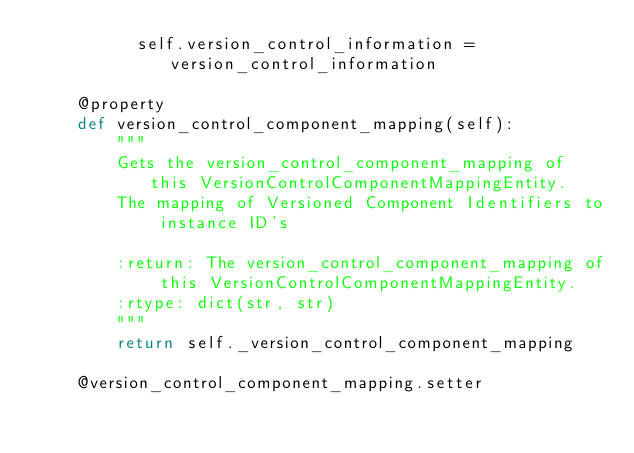Convert code to text. <code><loc_0><loc_0><loc_500><loc_500><_Python_>          self.version_control_information = version_control_information

    @property
    def version_control_component_mapping(self):
        """
        Gets the version_control_component_mapping of this VersionControlComponentMappingEntity.
        The mapping of Versioned Component Identifiers to instance ID's

        :return: The version_control_component_mapping of this VersionControlComponentMappingEntity.
        :rtype: dict(str, str)
        """
        return self._version_control_component_mapping

    @version_control_component_mapping.setter</code> 